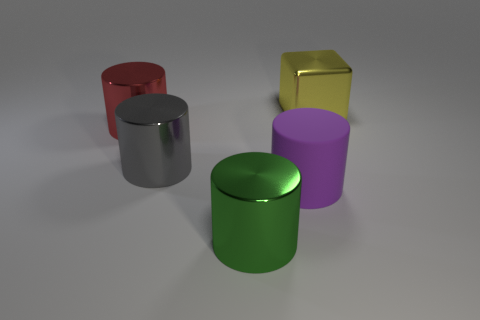What shape is the green shiny object that is the same size as the matte cylinder?
Keep it short and to the point. Cylinder. Is there a tiny blue object of the same shape as the green shiny object?
Provide a short and direct response. No. Is there a big cube in front of the shiny thing right of the metal object in front of the purple cylinder?
Give a very brief answer. No. Is the number of purple matte things that are to the left of the purple matte thing greater than the number of big cylinders that are left of the green object?
Offer a very short reply. No. There is a green thing that is the same size as the gray shiny thing; what material is it?
Your response must be concise. Metal. How many tiny objects are green objects or brown matte balls?
Keep it short and to the point. 0. Do the big red shiny object and the green thing have the same shape?
Provide a short and direct response. Yes. What number of large shiny objects are both behind the large green metallic cylinder and left of the metallic cube?
Provide a short and direct response. 2. Are there any other things that have the same color as the rubber thing?
Ensure brevity in your answer.  No. There is a big red thing that is made of the same material as the yellow cube; what is its shape?
Your answer should be very brief. Cylinder. 